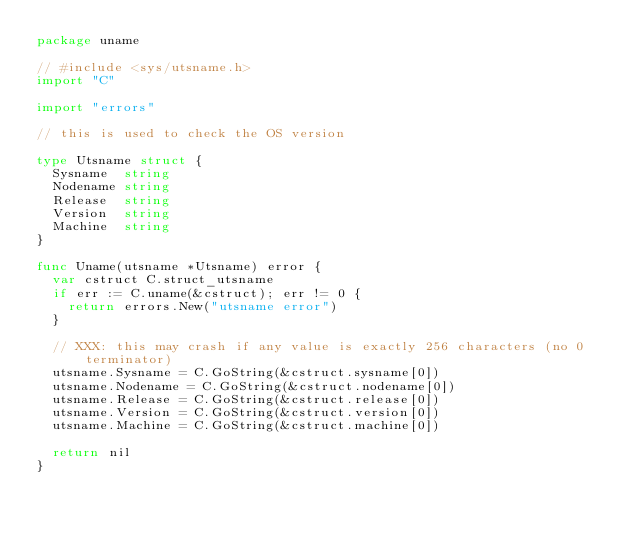<code> <loc_0><loc_0><loc_500><loc_500><_Go_>package uname

// #include <sys/utsname.h>
import "C"

import "errors"

// this is used to check the OS version

type Utsname struct {
	Sysname  string
	Nodename string
	Release  string
	Version  string
	Machine  string
}

func Uname(utsname *Utsname) error {
	var cstruct C.struct_utsname
	if err := C.uname(&cstruct); err != 0 {
		return errors.New("utsname error")
	}

	// XXX: this may crash if any value is exactly 256 characters (no 0 terminator)
	utsname.Sysname = C.GoString(&cstruct.sysname[0])
	utsname.Nodename = C.GoString(&cstruct.nodename[0])
	utsname.Release = C.GoString(&cstruct.release[0])
	utsname.Version = C.GoString(&cstruct.version[0])
	utsname.Machine = C.GoString(&cstruct.machine[0])

	return nil
}
</code> 